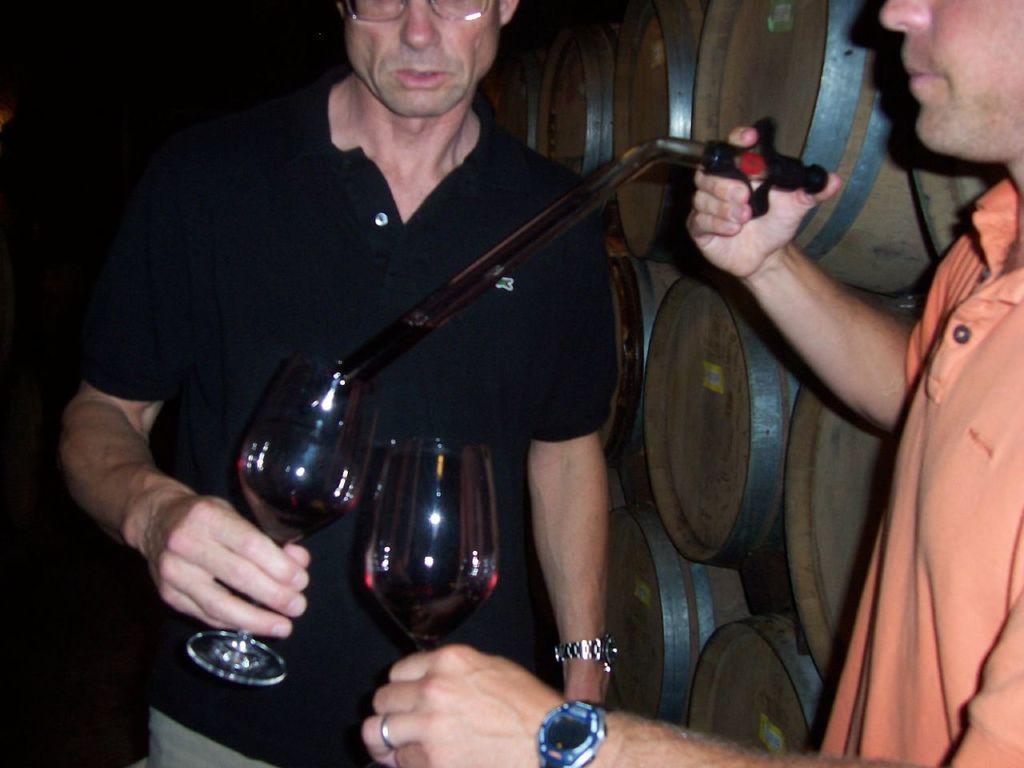Please provide a concise description of this image. In the middle of the image a man is standing and holding a glass. Bottom right side of the image a man is standing and holding a glass. 